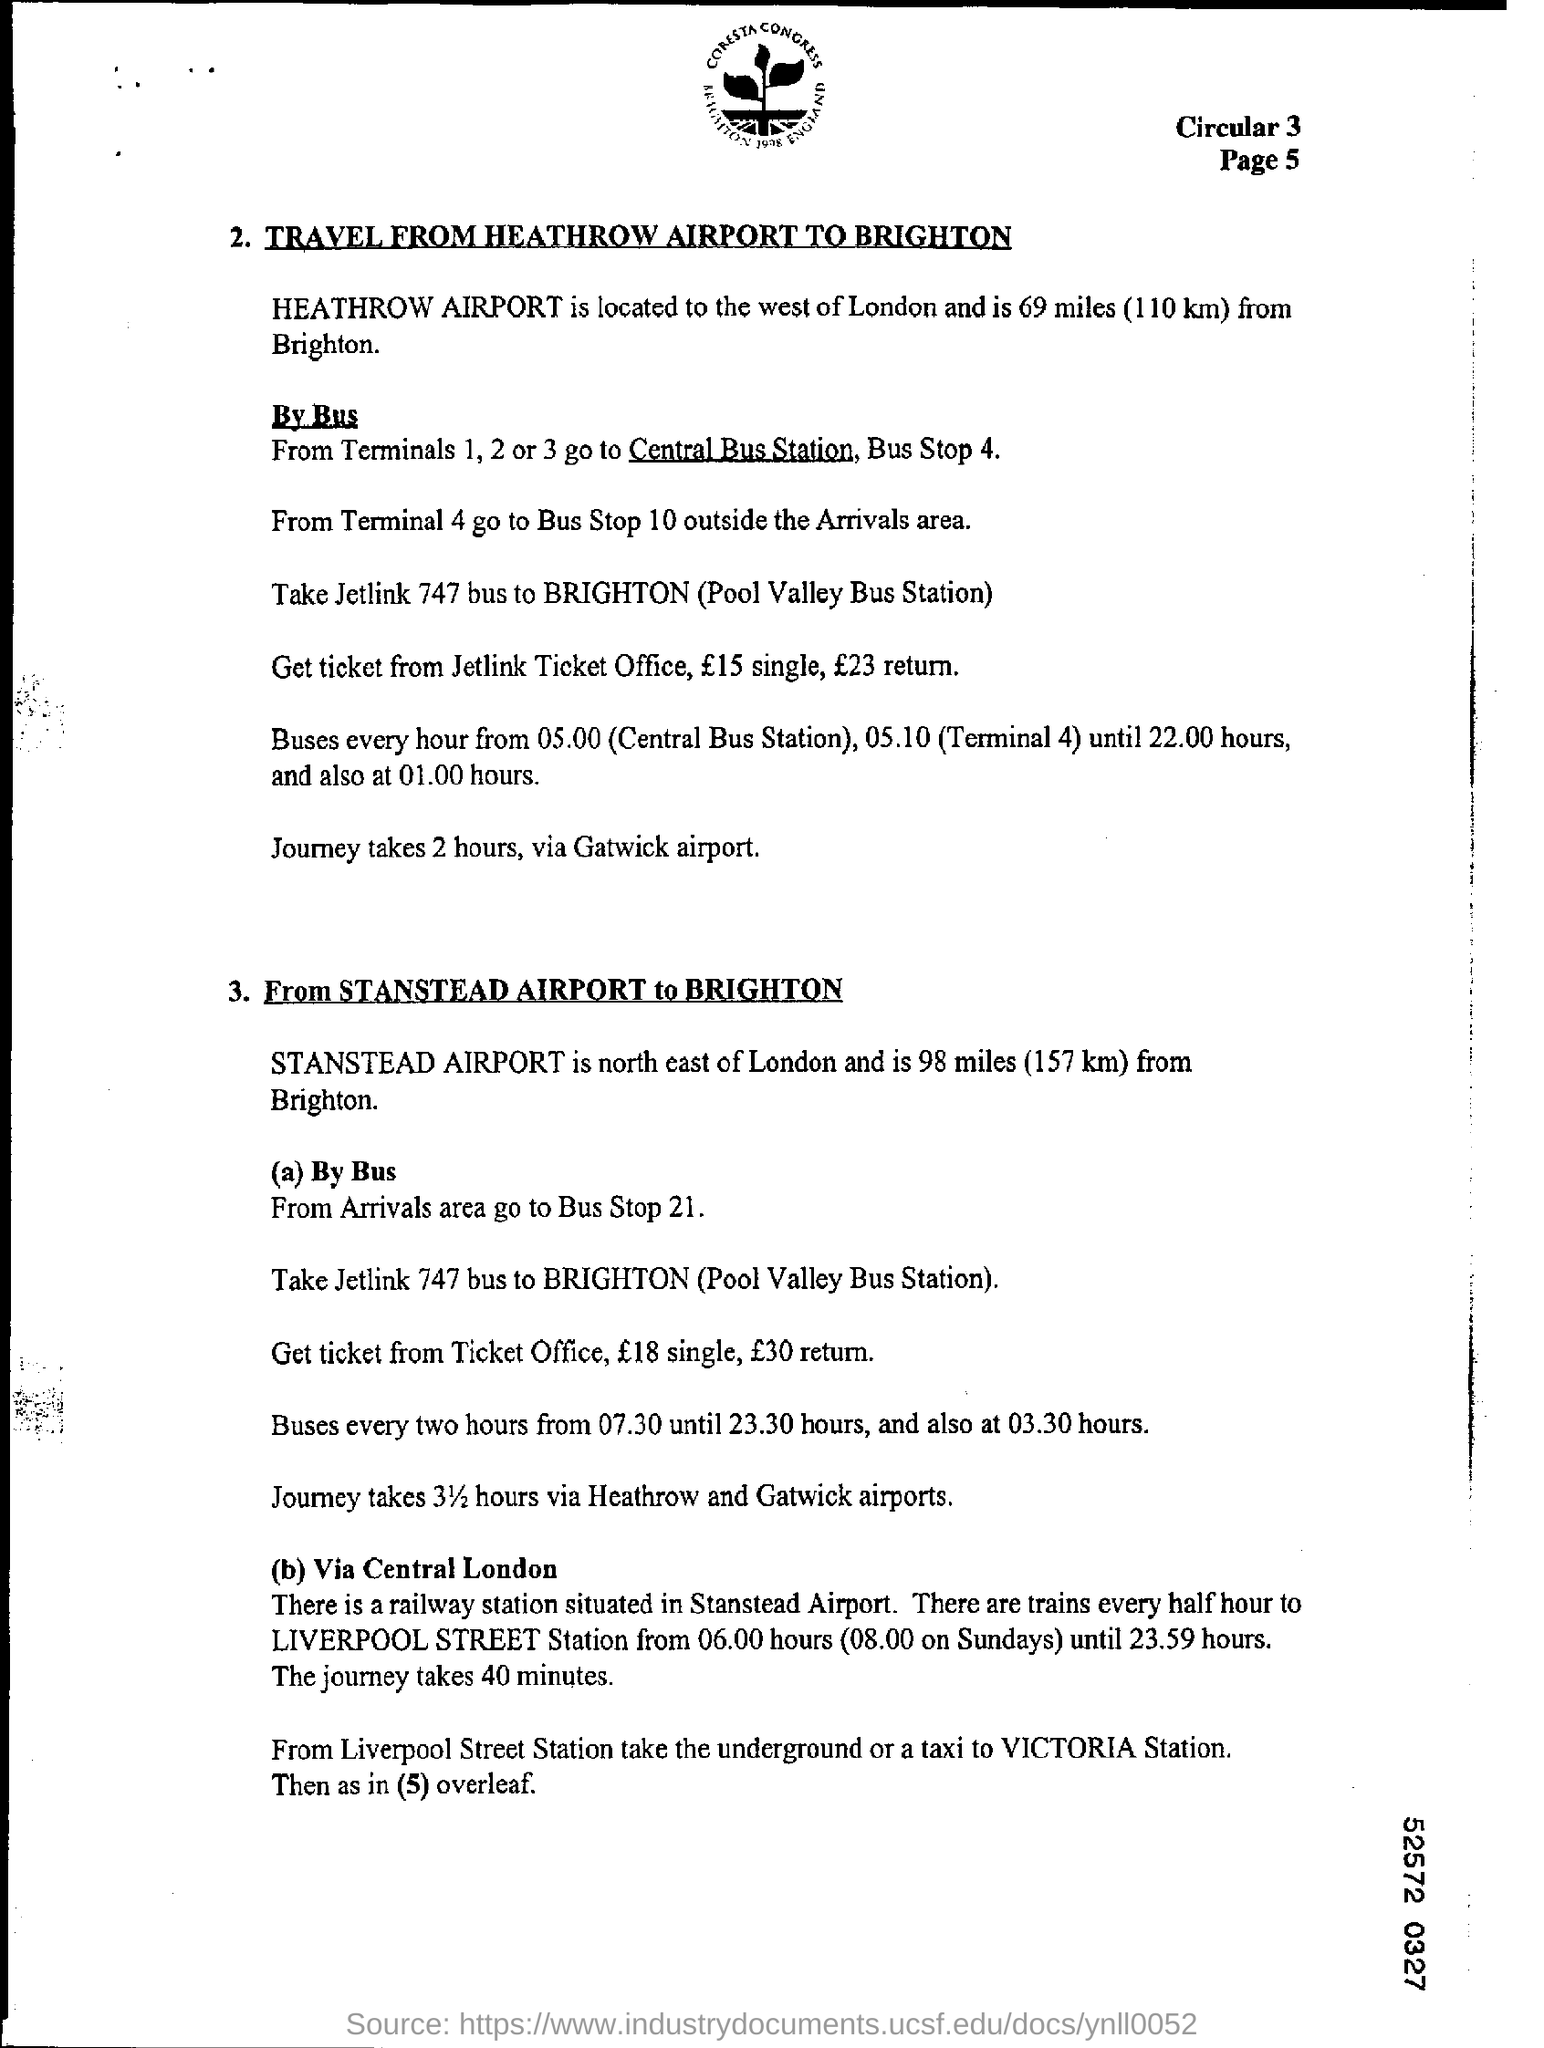Mention the page number at top right corner of the page ?
Give a very brief answer. Page 5. What bus must be taken to brighton ?
Give a very brief answer. Jetlink 747. 